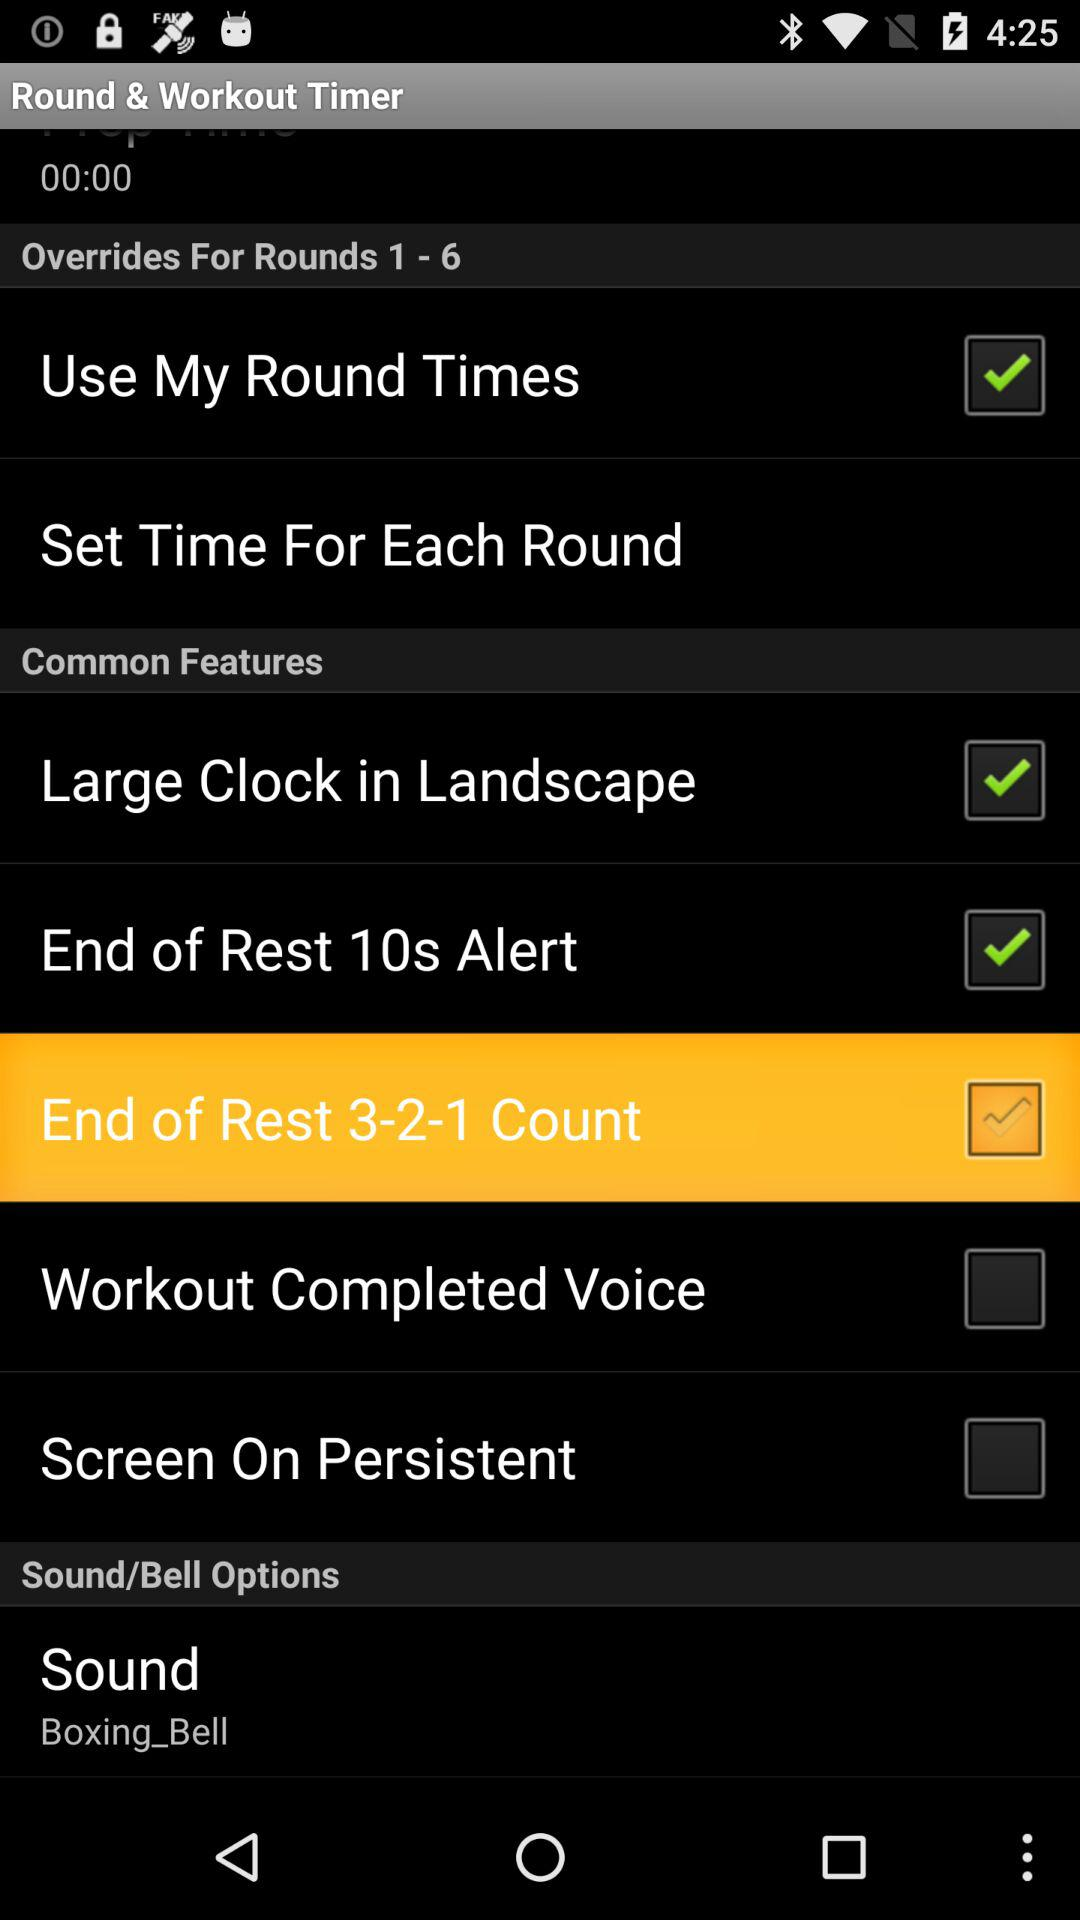What is the status of "Use My Round Times"? The status is "on". 